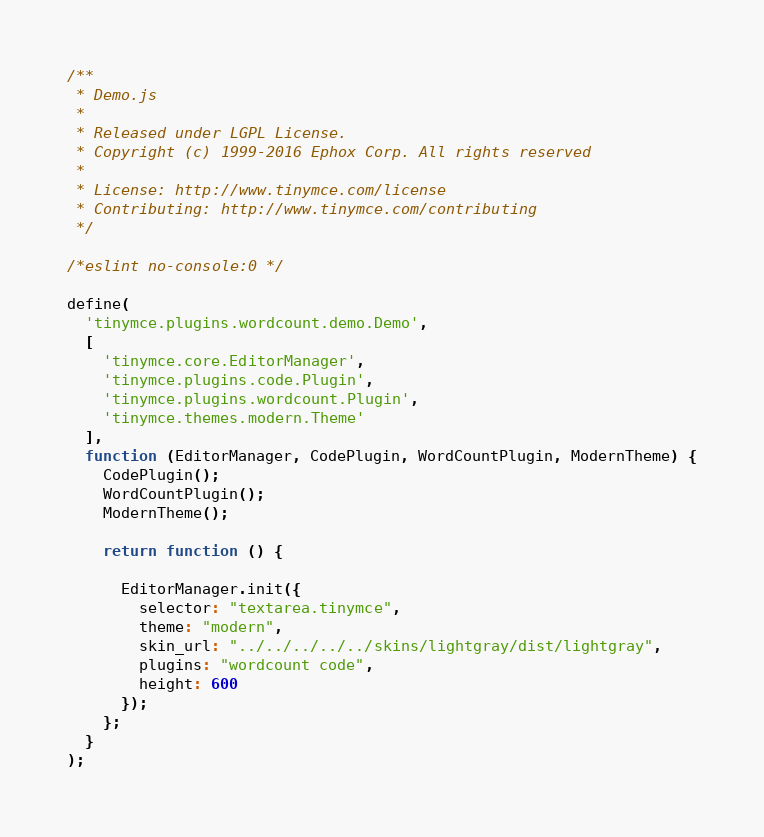<code> <loc_0><loc_0><loc_500><loc_500><_JavaScript_>/**
 * Demo.js
 *
 * Released under LGPL License.
 * Copyright (c) 1999-2016 Ephox Corp. All rights reserved
 *
 * License: http://www.tinymce.com/license
 * Contributing: http://www.tinymce.com/contributing
 */

/*eslint no-console:0 */

define(
  'tinymce.plugins.wordcount.demo.Demo',
  [
    'tinymce.core.EditorManager',
    'tinymce.plugins.code.Plugin',
    'tinymce.plugins.wordcount.Plugin',
    'tinymce.themes.modern.Theme'
  ],
  function (EditorManager, CodePlugin, WordCountPlugin, ModernTheme) {
    CodePlugin();
    WordCountPlugin();
    ModernTheme();

    return function () {

      EditorManager.init({
        selector: "textarea.tinymce",
        theme: "modern",
        skin_url: "../../../../../skins/lightgray/dist/lightgray",
        plugins: "wordcount code",
        height: 600
      });
    };
  }
);
</code> 